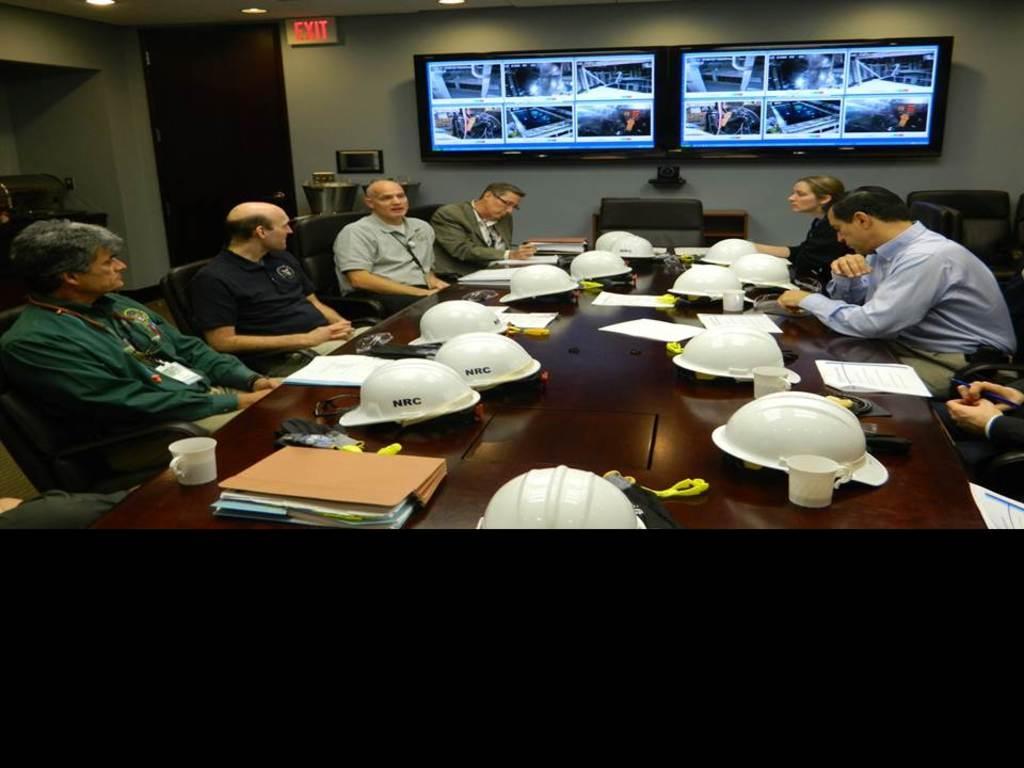In one or two sentences, can you explain what this image depicts? In this image we can see a group of people sitting on the chairs beside a table containing a group of helmets, files, books, papers, cups and some objects placed on it. On the backside we can see some containers, devices, a cupboard, a signboard, the televisions on a wall, a door and a roof with some ceiling lights. 